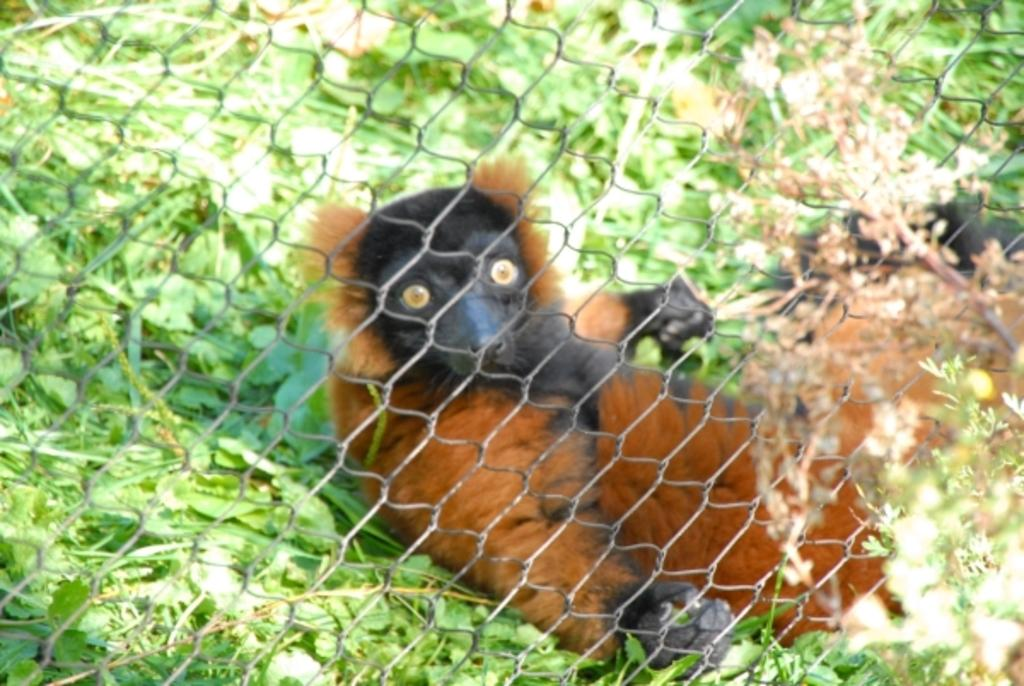What type of creature is in the image? There is an animal in the image. What colors can be seen on the animal? The animal is in brown and black colors. What is the animal doing in the image? The animal is resting on the ground. What can be seen in the background of the image? There is fencing in the image. What type of vegetation is present in the image? There are green leaves in the image. What type of pies is the queen eating in the image? There is no queen or pies present in the image; it features an animal resting on the ground. What branch is the animal holding in the image? There is no branch present in the image; the animal is resting on the ground. 